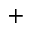<formula> <loc_0><loc_0><loc_500><loc_500>^ { + }</formula> 